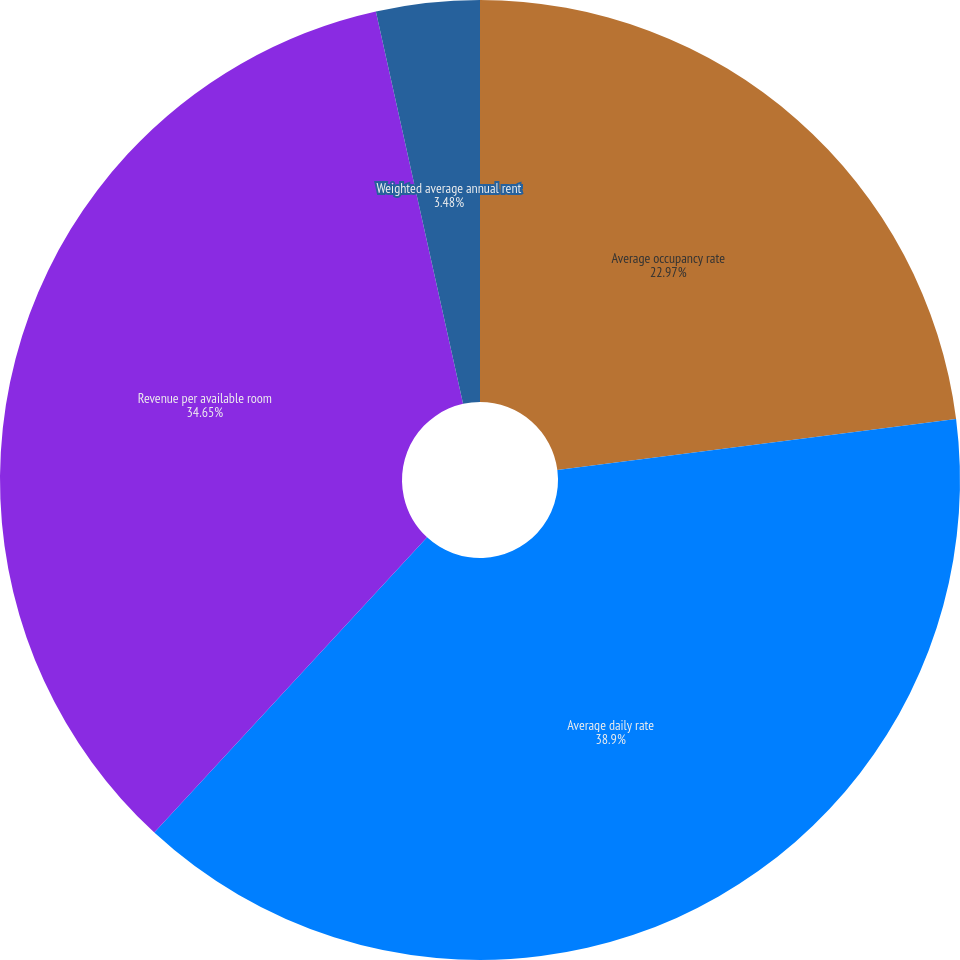Convert chart. <chart><loc_0><loc_0><loc_500><loc_500><pie_chart><fcel>Average occupancy rate<fcel>Average daily rate<fcel>Revenue per available room<fcel>Weighted average annual rent<nl><fcel>22.97%<fcel>38.9%<fcel>34.65%<fcel>3.48%<nl></chart> 